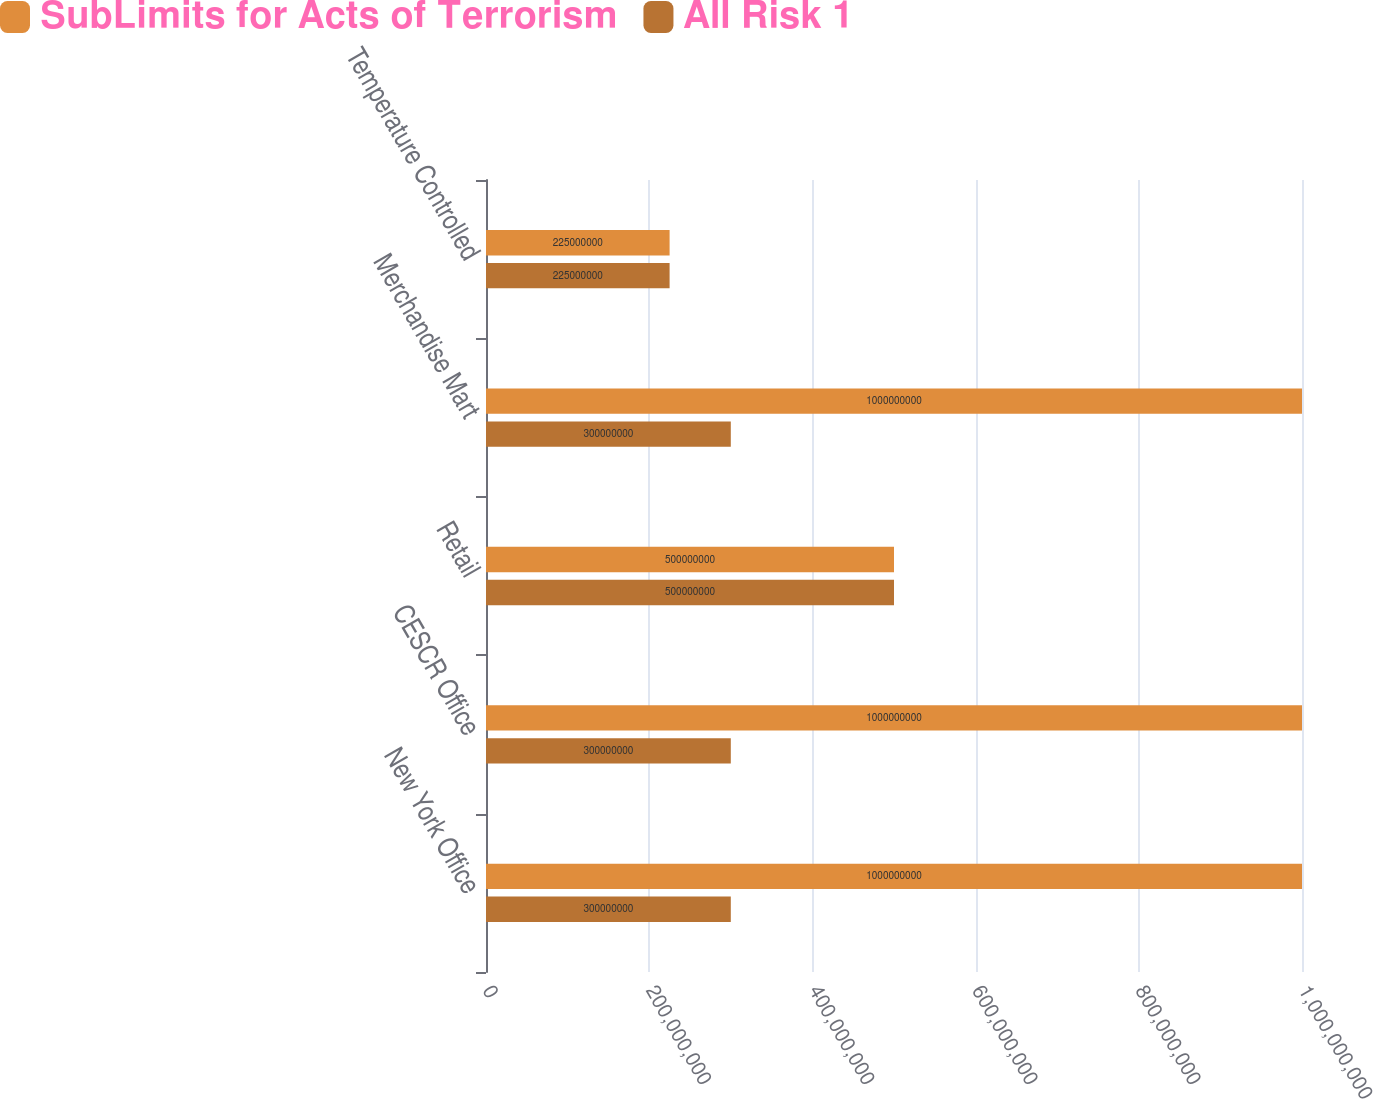Convert chart to OTSL. <chart><loc_0><loc_0><loc_500><loc_500><stacked_bar_chart><ecel><fcel>New York Office<fcel>CESCR Office<fcel>Retail<fcel>Merchandise Mart<fcel>Temperature Controlled<nl><fcel>SubLimits for Acts of Terrorism<fcel>1e+09<fcel>1e+09<fcel>5e+08<fcel>1e+09<fcel>2.25e+08<nl><fcel>All Risk 1<fcel>3e+08<fcel>3e+08<fcel>5e+08<fcel>3e+08<fcel>2.25e+08<nl></chart> 